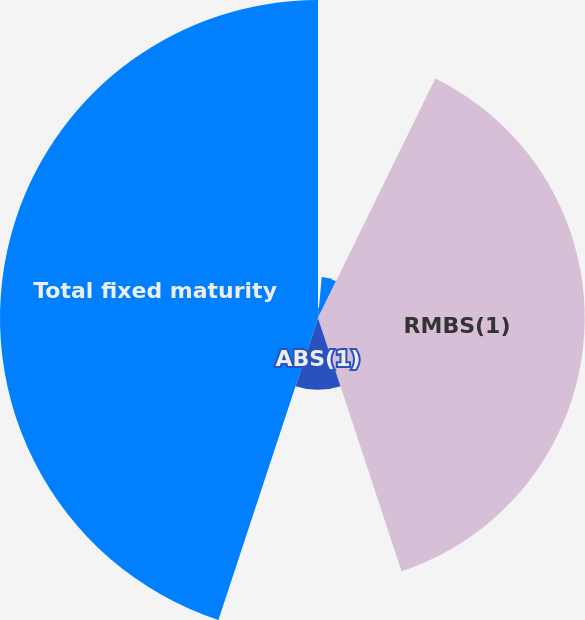Convert chart. <chart><loc_0><loc_0><loc_500><loc_500><pie_chart><fcel>US corporate securities<fcel>Foreign corporate securities<fcel>RMBS(1)<fcel>ABS(1)<fcel>Total fixed maturity<nl><fcel>1.45%<fcel>5.8%<fcel>37.68%<fcel>10.14%<fcel>44.93%<nl></chart> 